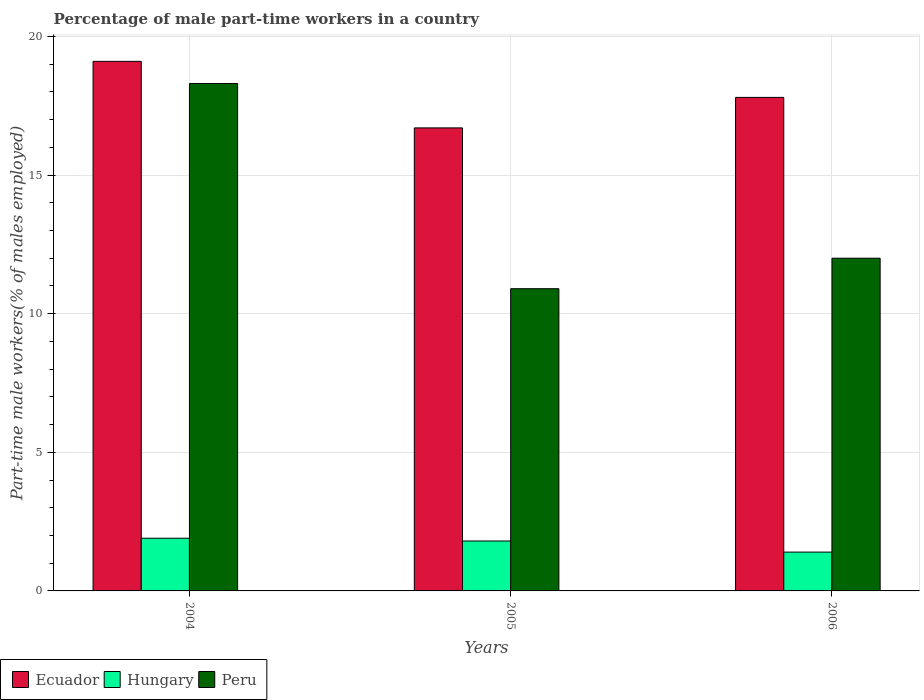How many different coloured bars are there?
Provide a succinct answer. 3. How many bars are there on the 2nd tick from the left?
Offer a terse response. 3. How many bars are there on the 3rd tick from the right?
Offer a very short reply. 3. What is the label of the 2nd group of bars from the left?
Your response must be concise. 2005. In how many cases, is the number of bars for a given year not equal to the number of legend labels?
Provide a succinct answer. 0. What is the percentage of male part-time workers in Hungary in 2006?
Give a very brief answer. 1.4. Across all years, what is the maximum percentage of male part-time workers in Hungary?
Give a very brief answer. 1.9. Across all years, what is the minimum percentage of male part-time workers in Hungary?
Keep it short and to the point. 1.4. In which year was the percentage of male part-time workers in Ecuador maximum?
Keep it short and to the point. 2004. In which year was the percentage of male part-time workers in Ecuador minimum?
Your response must be concise. 2005. What is the total percentage of male part-time workers in Ecuador in the graph?
Offer a terse response. 53.6. What is the difference between the percentage of male part-time workers in Ecuador in 2004 and that in 2006?
Provide a short and direct response. 1.3. What is the difference between the percentage of male part-time workers in Peru in 2006 and the percentage of male part-time workers in Hungary in 2004?
Give a very brief answer. 10.1. What is the average percentage of male part-time workers in Peru per year?
Offer a terse response. 13.73. In the year 2006, what is the difference between the percentage of male part-time workers in Ecuador and percentage of male part-time workers in Peru?
Offer a very short reply. 5.8. In how many years, is the percentage of male part-time workers in Ecuador greater than 14 %?
Provide a succinct answer. 3. What is the ratio of the percentage of male part-time workers in Peru in 2004 to that in 2005?
Make the answer very short. 1.68. Is the percentage of male part-time workers in Ecuador in 2005 less than that in 2006?
Ensure brevity in your answer.  Yes. What is the difference between the highest and the second highest percentage of male part-time workers in Peru?
Provide a succinct answer. 6.3. What is the difference between the highest and the lowest percentage of male part-time workers in Ecuador?
Your response must be concise. 2.4. What does the 2nd bar from the left in 2005 represents?
Your answer should be compact. Hungary. What does the 2nd bar from the right in 2004 represents?
Your answer should be compact. Hungary. Is it the case that in every year, the sum of the percentage of male part-time workers in Peru and percentage of male part-time workers in Hungary is greater than the percentage of male part-time workers in Ecuador?
Offer a very short reply. No. How many bars are there?
Keep it short and to the point. 9. How many legend labels are there?
Give a very brief answer. 3. What is the title of the graph?
Offer a very short reply. Percentage of male part-time workers in a country. Does "Morocco" appear as one of the legend labels in the graph?
Provide a short and direct response. No. What is the label or title of the Y-axis?
Keep it short and to the point. Part-time male workers(% of males employed). What is the Part-time male workers(% of males employed) in Ecuador in 2004?
Make the answer very short. 19.1. What is the Part-time male workers(% of males employed) of Hungary in 2004?
Keep it short and to the point. 1.9. What is the Part-time male workers(% of males employed) in Peru in 2004?
Provide a short and direct response. 18.3. What is the Part-time male workers(% of males employed) of Ecuador in 2005?
Offer a very short reply. 16.7. What is the Part-time male workers(% of males employed) of Hungary in 2005?
Keep it short and to the point. 1.8. What is the Part-time male workers(% of males employed) of Peru in 2005?
Offer a very short reply. 10.9. What is the Part-time male workers(% of males employed) of Ecuador in 2006?
Your response must be concise. 17.8. What is the Part-time male workers(% of males employed) of Hungary in 2006?
Your answer should be very brief. 1.4. Across all years, what is the maximum Part-time male workers(% of males employed) in Ecuador?
Provide a short and direct response. 19.1. Across all years, what is the maximum Part-time male workers(% of males employed) of Hungary?
Ensure brevity in your answer.  1.9. Across all years, what is the maximum Part-time male workers(% of males employed) of Peru?
Make the answer very short. 18.3. Across all years, what is the minimum Part-time male workers(% of males employed) of Ecuador?
Your response must be concise. 16.7. Across all years, what is the minimum Part-time male workers(% of males employed) of Hungary?
Your answer should be very brief. 1.4. Across all years, what is the minimum Part-time male workers(% of males employed) of Peru?
Offer a very short reply. 10.9. What is the total Part-time male workers(% of males employed) in Ecuador in the graph?
Ensure brevity in your answer.  53.6. What is the total Part-time male workers(% of males employed) in Peru in the graph?
Your answer should be very brief. 41.2. What is the difference between the Part-time male workers(% of males employed) in Peru in 2004 and that in 2005?
Offer a very short reply. 7.4. What is the difference between the Part-time male workers(% of males employed) in Ecuador in 2004 and that in 2006?
Provide a short and direct response. 1.3. What is the difference between the Part-time male workers(% of males employed) in Peru in 2004 and that in 2006?
Give a very brief answer. 6.3. What is the difference between the Part-time male workers(% of males employed) of Peru in 2005 and that in 2006?
Your response must be concise. -1.1. What is the difference between the Part-time male workers(% of males employed) in Hungary in 2004 and the Part-time male workers(% of males employed) in Peru in 2005?
Your answer should be very brief. -9. What is the difference between the Part-time male workers(% of males employed) in Ecuador in 2004 and the Part-time male workers(% of males employed) in Hungary in 2006?
Provide a succinct answer. 17.7. What is the difference between the Part-time male workers(% of males employed) of Ecuador in 2004 and the Part-time male workers(% of males employed) of Peru in 2006?
Offer a very short reply. 7.1. What is the difference between the Part-time male workers(% of males employed) of Hungary in 2005 and the Part-time male workers(% of males employed) of Peru in 2006?
Keep it short and to the point. -10.2. What is the average Part-time male workers(% of males employed) of Ecuador per year?
Your answer should be compact. 17.87. What is the average Part-time male workers(% of males employed) in Peru per year?
Your answer should be compact. 13.73. In the year 2004, what is the difference between the Part-time male workers(% of males employed) of Ecuador and Part-time male workers(% of males employed) of Peru?
Keep it short and to the point. 0.8. In the year 2004, what is the difference between the Part-time male workers(% of males employed) of Hungary and Part-time male workers(% of males employed) of Peru?
Offer a terse response. -16.4. In the year 2005, what is the difference between the Part-time male workers(% of males employed) of Ecuador and Part-time male workers(% of males employed) of Hungary?
Give a very brief answer. 14.9. In the year 2005, what is the difference between the Part-time male workers(% of males employed) in Ecuador and Part-time male workers(% of males employed) in Peru?
Give a very brief answer. 5.8. In the year 2006, what is the difference between the Part-time male workers(% of males employed) in Ecuador and Part-time male workers(% of males employed) in Hungary?
Provide a succinct answer. 16.4. In the year 2006, what is the difference between the Part-time male workers(% of males employed) of Ecuador and Part-time male workers(% of males employed) of Peru?
Your answer should be very brief. 5.8. What is the ratio of the Part-time male workers(% of males employed) in Ecuador in 2004 to that in 2005?
Provide a short and direct response. 1.14. What is the ratio of the Part-time male workers(% of males employed) of Hungary in 2004 to that in 2005?
Give a very brief answer. 1.06. What is the ratio of the Part-time male workers(% of males employed) in Peru in 2004 to that in 2005?
Your answer should be very brief. 1.68. What is the ratio of the Part-time male workers(% of males employed) in Ecuador in 2004 to that in 2006?
Ensure brevity in your answer.  1.07. What is the ratio of the Part-time male workers(% of males employed) in Hungary in 2004 to that in 2006?
Ensure brevity in your answer.  1.36. What is the ratio of the Part-time male workers(% of males employed) of Peru in 2004 to that in 2006?
Your answer should be very brief. 1.52. What is the ratio of the Part-time male workers(% of males employed) of Ecuador in 2005 to that in 2006?
Offer a very short reply. 0.94. What is the ratio of the Part-time male workers(% of males employed) in Hungary in 2005 to that in 2006?
Keep it short and to the point. 1.29. What is the ratio of the Part-time male workers(% of males employed) of Peru in 2005 to that in 2006?
Provide a succinct answer. 0.91. What is the difference between the highest and the second highest Part-time male workers(% of males employed) of Hungary?
Your answer should be compact. 0.1. What is the difference between the highest and the lowest Part-time male workers(% of males employed) in Hungary?
Give a very brief answer. 0.5. What is the difference between the highest and the lowest Part-time male workers(% of males employed) in Peru?
Give a very brief answer. 7.4. 